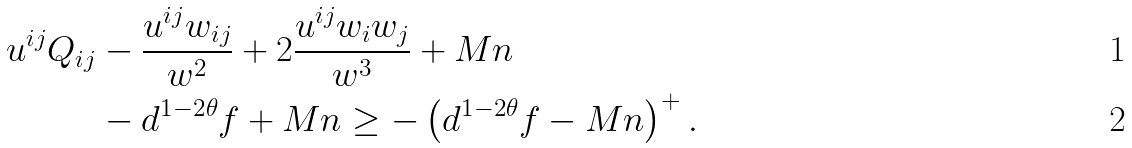Convert formula to latex. <formula><loc_0><loc_0><loc_500><loc_500>u ^ { i j } Q _ { i j } & - \frac { u ^ { i j } w _ { i j } } { w ^ { 2 } } + 2 \frac { u ^ { i j } w _ { i } w _ { j } } { w ^ { 3 } } + M n \\ & - d ^ { 1 - 2 \theta } f + M n \geq - \left ( d ^ { 1 - 2 \theta } f - M n \right ) ^ { + } .</formula> 